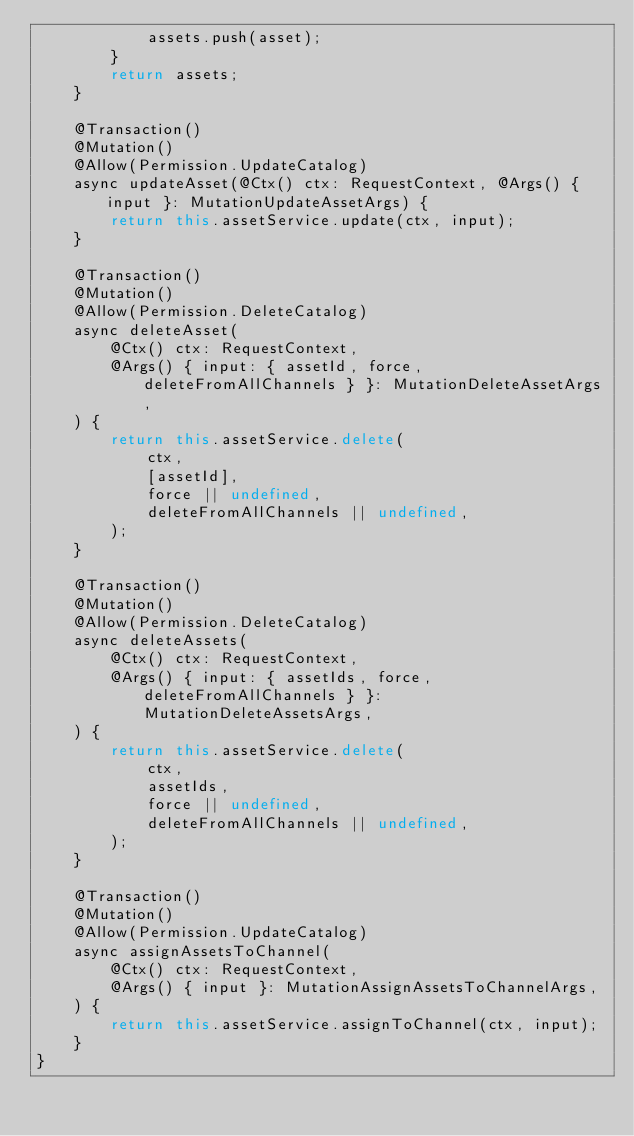Convert code to text. <code><loc_0><loc_0><loc_500><loc_500><_TypeScript_>            assets.push(asset);
        }
        return assets;
    }

    @Transaction()
    @Mutation()
    @Allow(Permission.UpdateCatalog)
    async updateAsset(@Ctx() ctx: RequestContext, @Args() { input }: MutationUpdateAssetArgs) {
        return this.assetService.update(ctx, input);
    }

    @Transaction()
    @Mutation()
    @Allow(Permission.DeleteCatalog)
    async deleteAsset(
        @Ctx() ctx: RequestContext,
        @Args() { input: { assetId, force, deleteFromAllChannels } }: MutationDeleteAssetArgs,
    ) {
        return this.assetService.delete(
            ctx,
            [assetId],
            force || undefined,
            deleteFromAllChannels || undefined,
        );
    }

    @Transaction()
    @Mutation()
    @Allow(Permission.DeleteCatalog)
    async deleteAssets(
        @Ctx() ctx: RequestContext,
        @Args() { input: { assetIds, force, deleteFromAllChannels } }: MutationDeleteAssetsArgs,
    ) {
        return this.assetService.delete(
            ctx,
            assetIds,
            force || undefined,
            deleteFromAllChannels || undefined,
        );
    }

    @Transaction()
    @Mutation()
    @Allow(Permission.UpdateCatalog)
    async assignAssetsToChannel(
        @Ctx() ctx: RequestContext,
        @Args() { input }: MutationAssignAssetsToChannelArgs,
    ) {
        return this.assetService.assignToChannel(ctx, input);
    }
}
</code> 